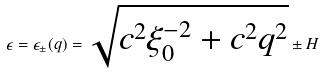<formula> <loc_0><loc_0><loc_500><loc_500>\epsilon = \epsilon _ { \pm } ( q ) = \sqrt { c ^ { 2 } \xi _ { 0 } ^ { - 2 } + c ^ { 2 } q ^ { 2 } } \pm H</formula> 